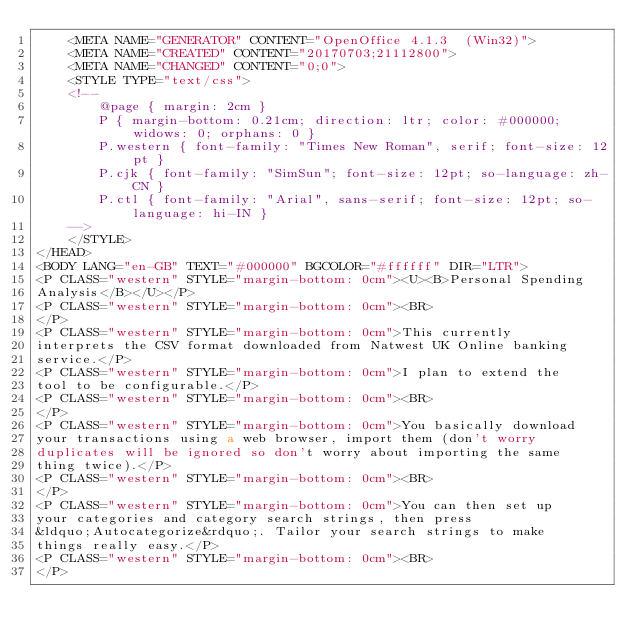Convert code to text. <code><loc_0><loc_0><loc_500><loc_500><_HTML_>	<META NAME="GENERATOR" CONTENT="OpenOffice 4.1.3  (Win32)">
	<META NAME="CREATED" CONTENT="20170703;21112800">
	<META NAME="CHANGED" CONTENT="0;0">
	<STYLE TYPE="text/css">
	<!--
		@page { margin: 2cm }
		P { margin-bottom: 0.21cm; direction: ltr; color: #000000; widows: 0; orphans: 0 }
		P.western { font-family: "Times New Roman", serif; font-size: 12pt }
		P.cjk { font-family: "SimSun"; font-size: 12pt; so-language: zh-CN }
		P.ctl { font-family: "Arial", sans-serif; font-size: 12pt; so-language: hi-IN }
	-->
	</STYLE>
</HEAD>
<BODY LANG="en-GB" TEXT="#000000" BGCOLOR="#ffffff" DIR="LTR">
<P CLASS="western" STYLE="margin-bottom: 0cm"><U><B>Personal Spending
Analysis</B></U></P>
<P CLASS="western" STYLE="margin-bottom: 0cm"><BR>
</P>
<P CLASS="western" STYLE="margin-bottom: 0cm">This currently
interprets the CSV format downloaded from Natwest UK Online banking
service.</P>
<P CLASS="western" STYLE="margin-bottom: 0cm">I plan to extend the
tool to be configurable.</P>
<P CLASS="western" STYLE="margin-bottom: 0cm"><BR>
</P>
<P CLASS="western" STYLE="margin-bottom: 0cm">You basically download
your transactions using a web browser, import them (don't worry
duplicates will be ignored so don't worry about importing the same
thing twice).</P>
<P CLASS="western" STYLE="margin-bottom: 0cm"><BR>
</P>
<P CLASS="western" STYLE="margin-bottom: 0cm">You can then set up
your categories and category search strings, then press
&ldquo;Autocategorize&rdquo;. Tailor your search strings to make
things really easy.</P>
<P CLASS="western" STYLE="margin-bottom: 0cm"><BR>
</P></code> 